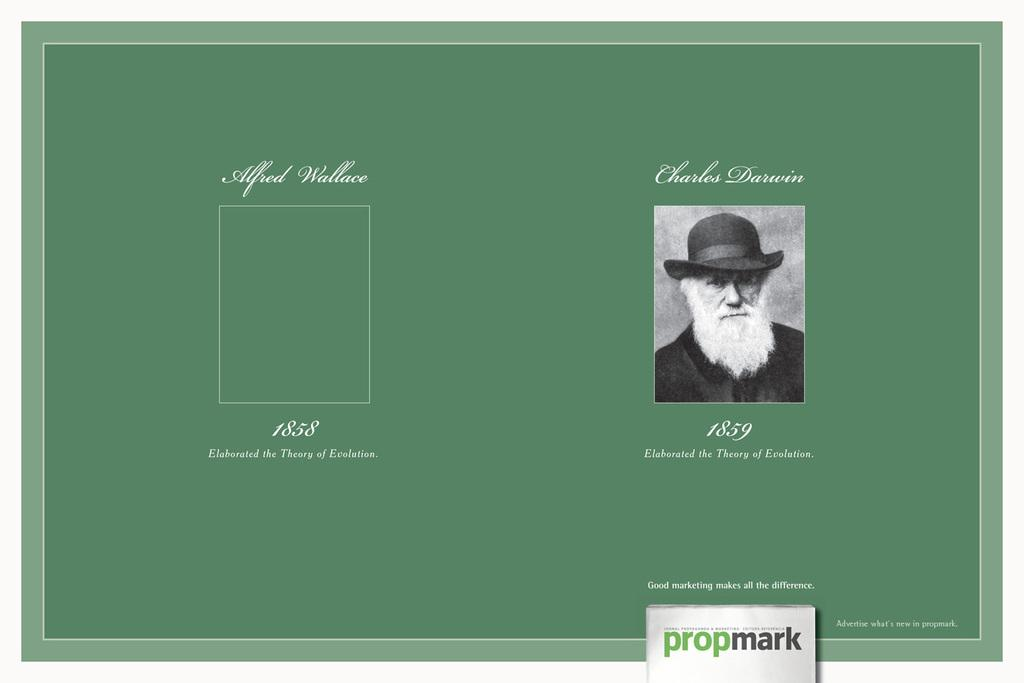What is the main subject of the image? There is a photograph of a man in the image. What is the background of the photograph? The photograph is pasted on a green color sheet. Are there any words or letters visible in the image? Yes, there is text visible in the image. How many beads are hanging from the man's neck in the image? There are no beads visible in the image; the man is depicted in a photograph. What type of recess can be seen in the image? There is no recess present in the image; it features a photograph of a man pasted on a green color sheet with text. 